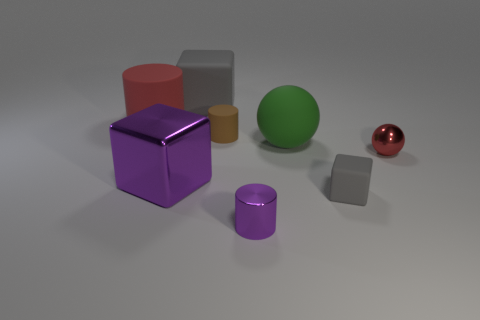What material is the purple cube left of the small red metal sphere?
Keep it short and to the point. Metal. How many shiny cylinders have the same color as the metallic block?
Make the answer very short. 1. There is a big matte ball; is it the same color as the block that is to the right of the large gray cube?
Your response must be concise. No. Are there fewer tiny gray spheres than tiny red objects?
Keep it short and to the point. Yes. Is the number of red metallic objects that are left of the small purple object greater than the number of large gray cubes that are behind the big gray matte object?
Ensure brevity in your answer.  No. Is the big green sphere made of the same material as the small brown object?
Your response must be concise. Yes. There is a gray object to the right of the metal cylinder; what number of tiny brown cylinders are on the left side of it?
Offer a very short reply. 1. There is a cube behind the large red object; does it have the same color as the big rubber cylinder?
Make the answer very short. No. What number of objects are either big metallic balls or objects left of the small gray block?
Provide a short and direct response. 6. There is a gray matte thing right of the green thing; is it the same shape as the purple object behind the tiny block?
Keep it short and to the point. Yes. 